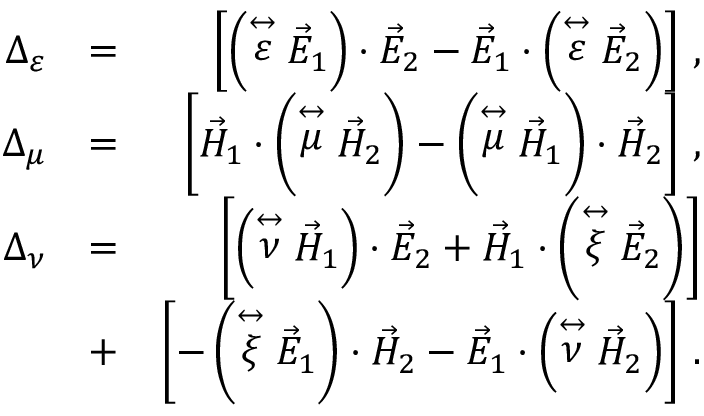<formula> <loc_0><loc_0><loc_500><loc_500>\begin{array} { r l r } { \Delta _ { \varepsilon } } & { = } & { \left [ \left ( \stackrel { \leftrightarrow } { \varepsilon } \vec { E } _ { 1 } \right ) \cdot \vec { E } _ { 2 } - \vec { E } _ { 1 } \cdot \left ( \stackrel { \leftrightarrow } { \varepsilon } \vec { E } _ { 2 } \right ) \right ] \, , } \\ { \Delta _ { \mu } } & { = } & { \left [ \vec { H } _ { 1 } \cdot \left ( \stackrel { \leftrightarrow } { \mu } \vec { H } _ { 2 } \right ) - \left ( \stackrel { \leftrightarrow } { \mu } \vec { H } _ { 1 } \right ) \cdot \vec { H } _ { 2 } \right ] \, , } \\ { \Delta _ { \nu } } & { = } & { \left [ \left ( \stackrel { \leftrightarrow } { \nu } \vec { H } _ { 1 } \right ) \cdot \vec { E } _ { 2 } + \vec { H } _ { 1 } \cdot \left ( \stackrel { \leftrightarrow } { \xi } \vec { E } _ { 2 } \right ) \right ] } \\ & { + } & { \left [ - \left ( \stackrel { \leftrightarrow } { \xi } \vec { E } _ { 1 } \right ) \cdot \vec { H } _ { 2 } - \vec { E } _ { 1 } \cdot \left ( \stackrel { \leftrightarrow } { \nu } \vec { H } _ { 2 } \right ) \right ] \, . } \end{array}</formula> 